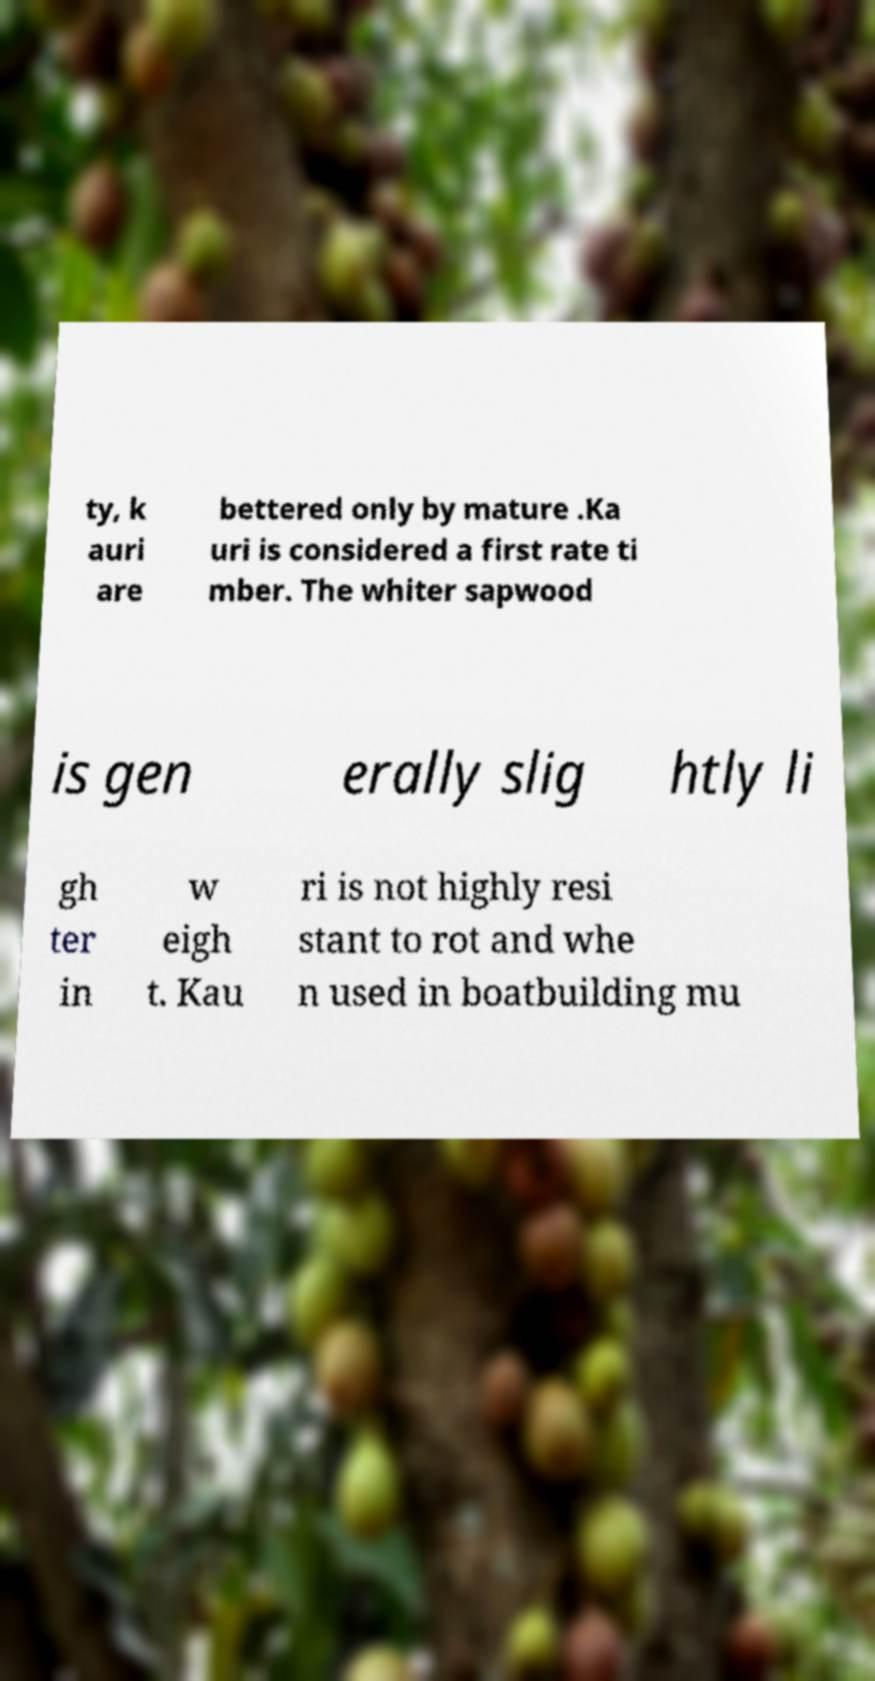Please identify and transcribe the text found in this image. ty, k auri are bettered only by mature .Ka uri is considered a first rate ti mber. The whiter sapwood is gen erally slig htly li gh ter in w eigh t. Kau ri is not highly resi stant to rot and whe n used in boatbuilding mu 